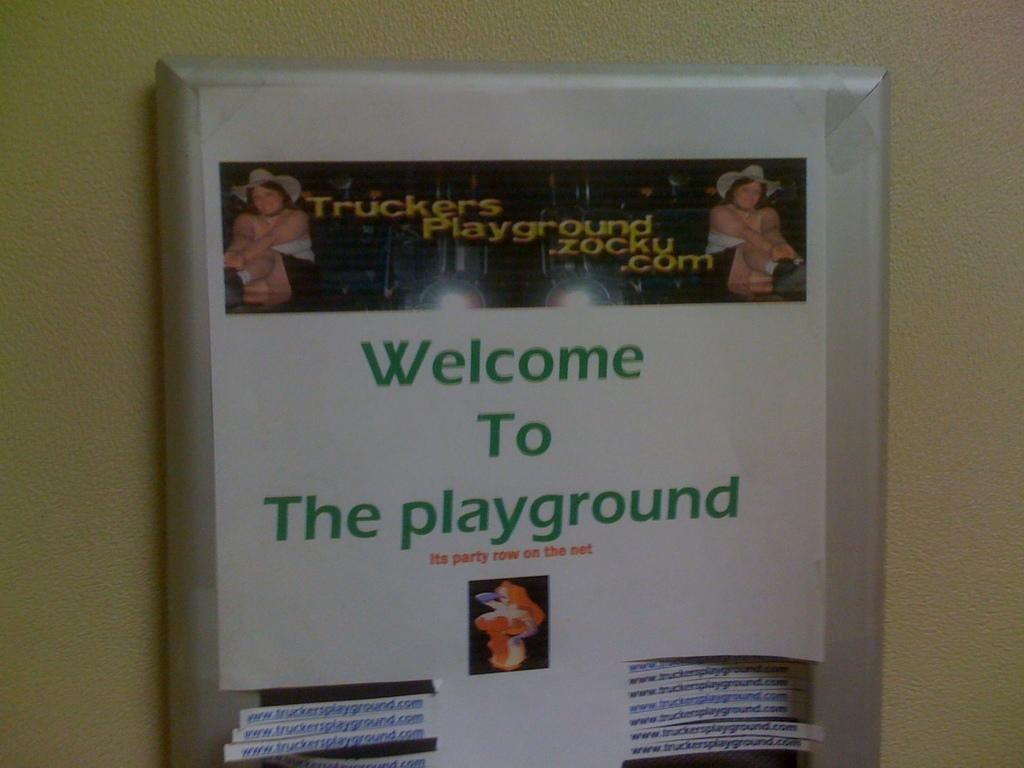<image>
Relay a brief, clear account of the picture shown. A Paper for Truckers Playground with tear off slips is hung in a common area. 